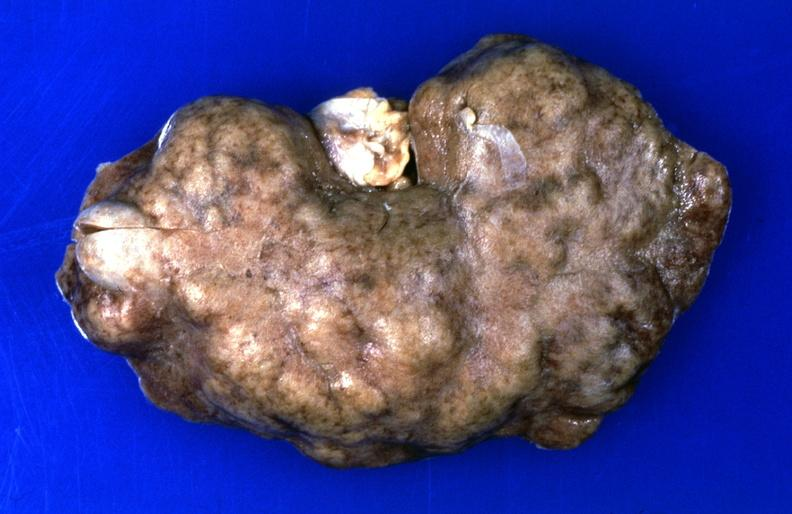does this image show kidney, hemochromatosis, chronic scarring?
Answer the question using a single word or phrase. Yes 